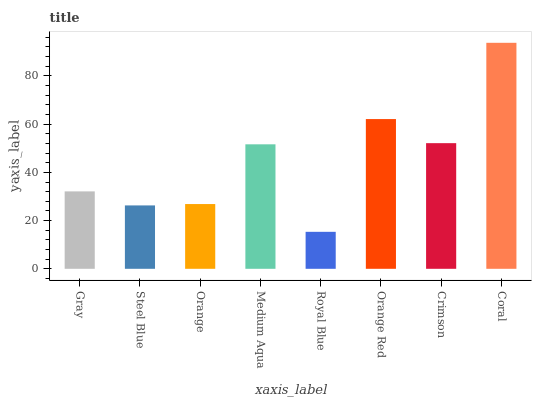Is Royal Blue the minimum?
Answer yes or no. Yes. Is Coral the maximum?
Answer yes or no. Yes. Is Steel Blue the minimum?
Answer yes or no. No. Is Steel Blue the maximum?
Answer yes or no. No. Is Gray greater than Steel Blue?
Answer yes or no. Yes. Is Steel Blue less than Gray?
Answer yes or no. Yes. Is Steel Blue greater than Gray?
Answer yes or no. No. Is Gray less than Steel Blue?
Answer yes or no. No. Is Medium Aqua the high median?
Answer yes or no. Yes. Is Gray the low median?
Answer yes or no. Yes. Is Orange Red the high median?
Answer yes or no. No. Is Orange the low median?
Answer yes or no. No. 